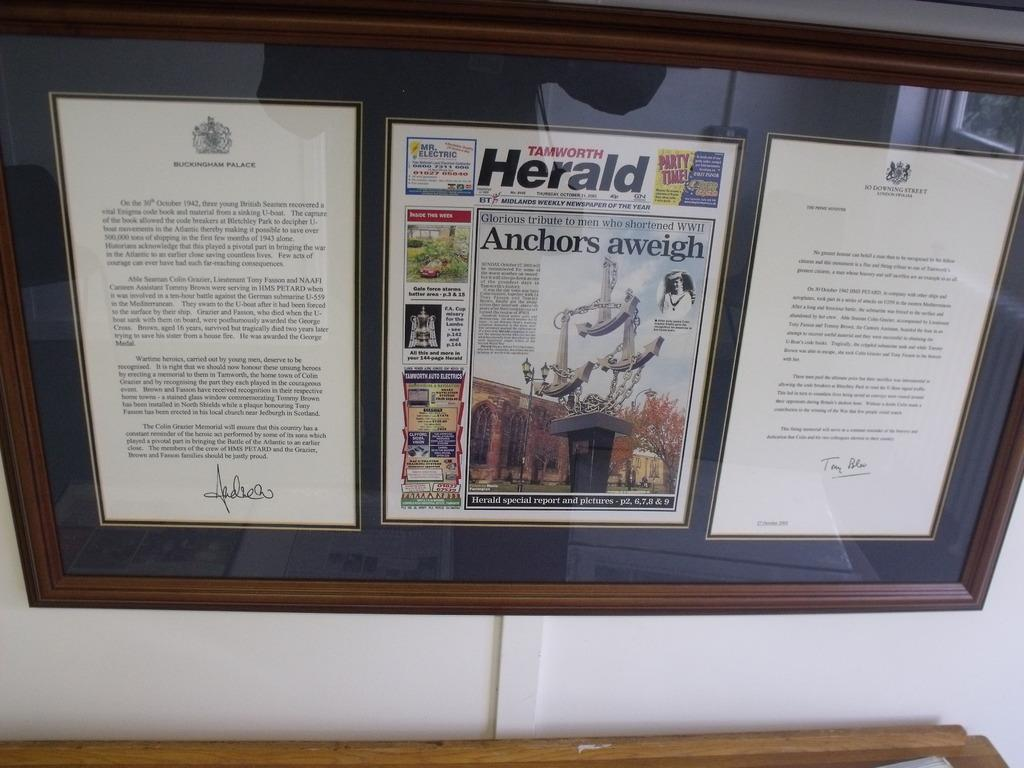<image>
Create a compact narrative representing the image presented. A framed copy of the Tamworth Herald and a letter from Buckingham Palace. 